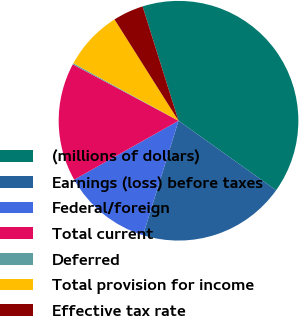<chart> <loc_0><loc_0><loc_500><loc_500><pie_chart><fcel>(millions of dollars)<fcel>Earnings (loss) before taxes<fcel>Federal/foreign<fcel>Total current<fcel>Deferred<fcel>Total provision for income<fcel>Effective tax rate<nl><fcel>39.7%<fcel>19.93%<fcel>12.03%<fcel>15.98%<fcel>0.17%<fcel>8.07%<fcel>4.12%<nl></chart> 